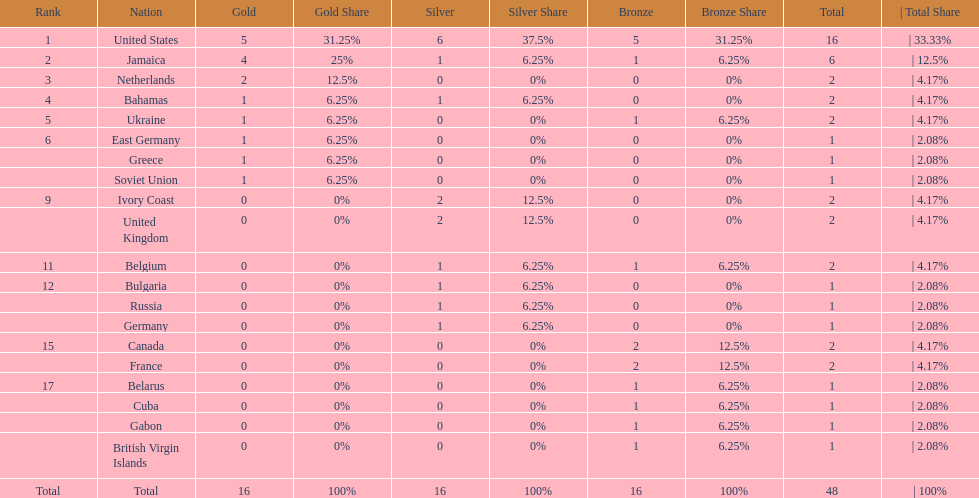Which countries won at least 3 silver medals? United States. 